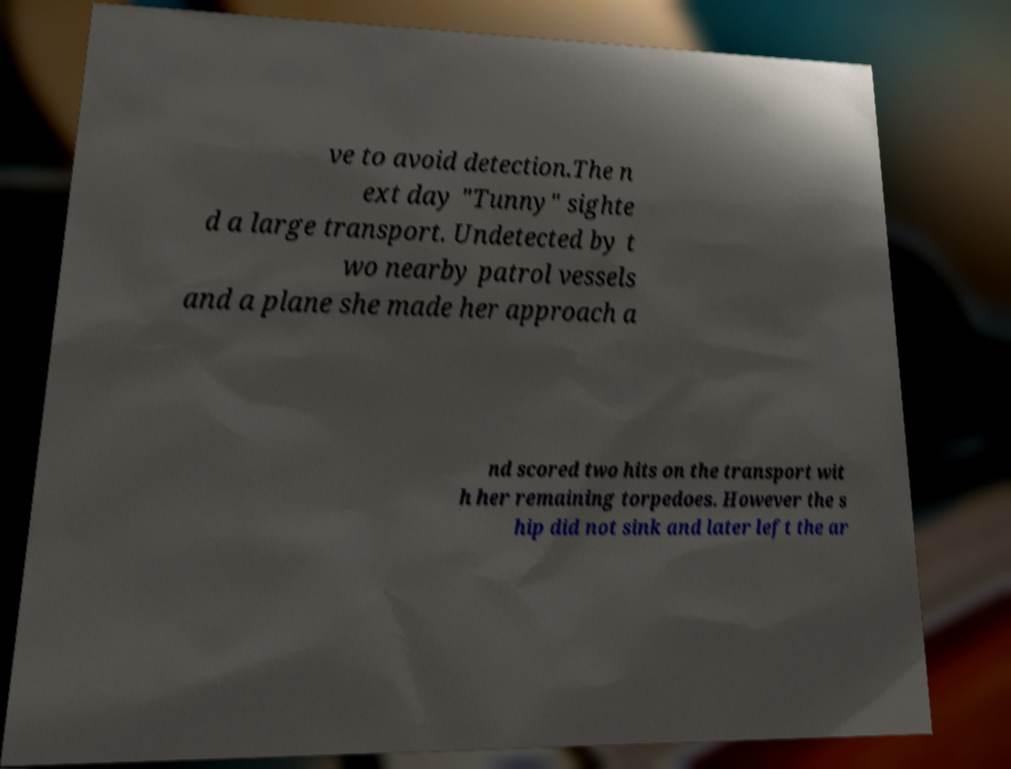Please identify and transcribe the text found in this image. ve to avoid detection.The n ext day "Tunny" sighte d a large transport. Undetected by t wo nearby patrol vessels and a plane she made her approach a nd scored two hits on the transport wit h her remaining torpedoes. However the s hip did not sink and later left the ar 